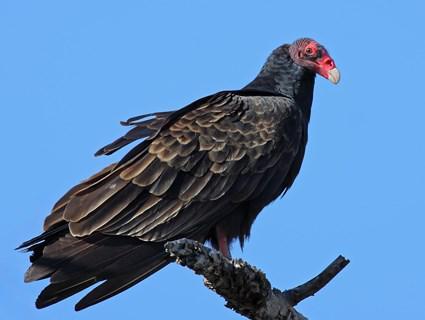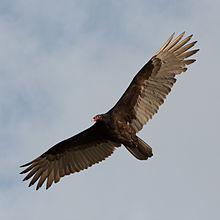The first image is the image on the left, the second image is the image on the right. For the images displayed, is the sentence "Both birds are facing the same direction." factually correct? Answer yes or no. No. The first image is the image on the left, the second image is the image on the right. For the images shown, is this caption "There are two vultures flying" true? Answer yes or no. No. 